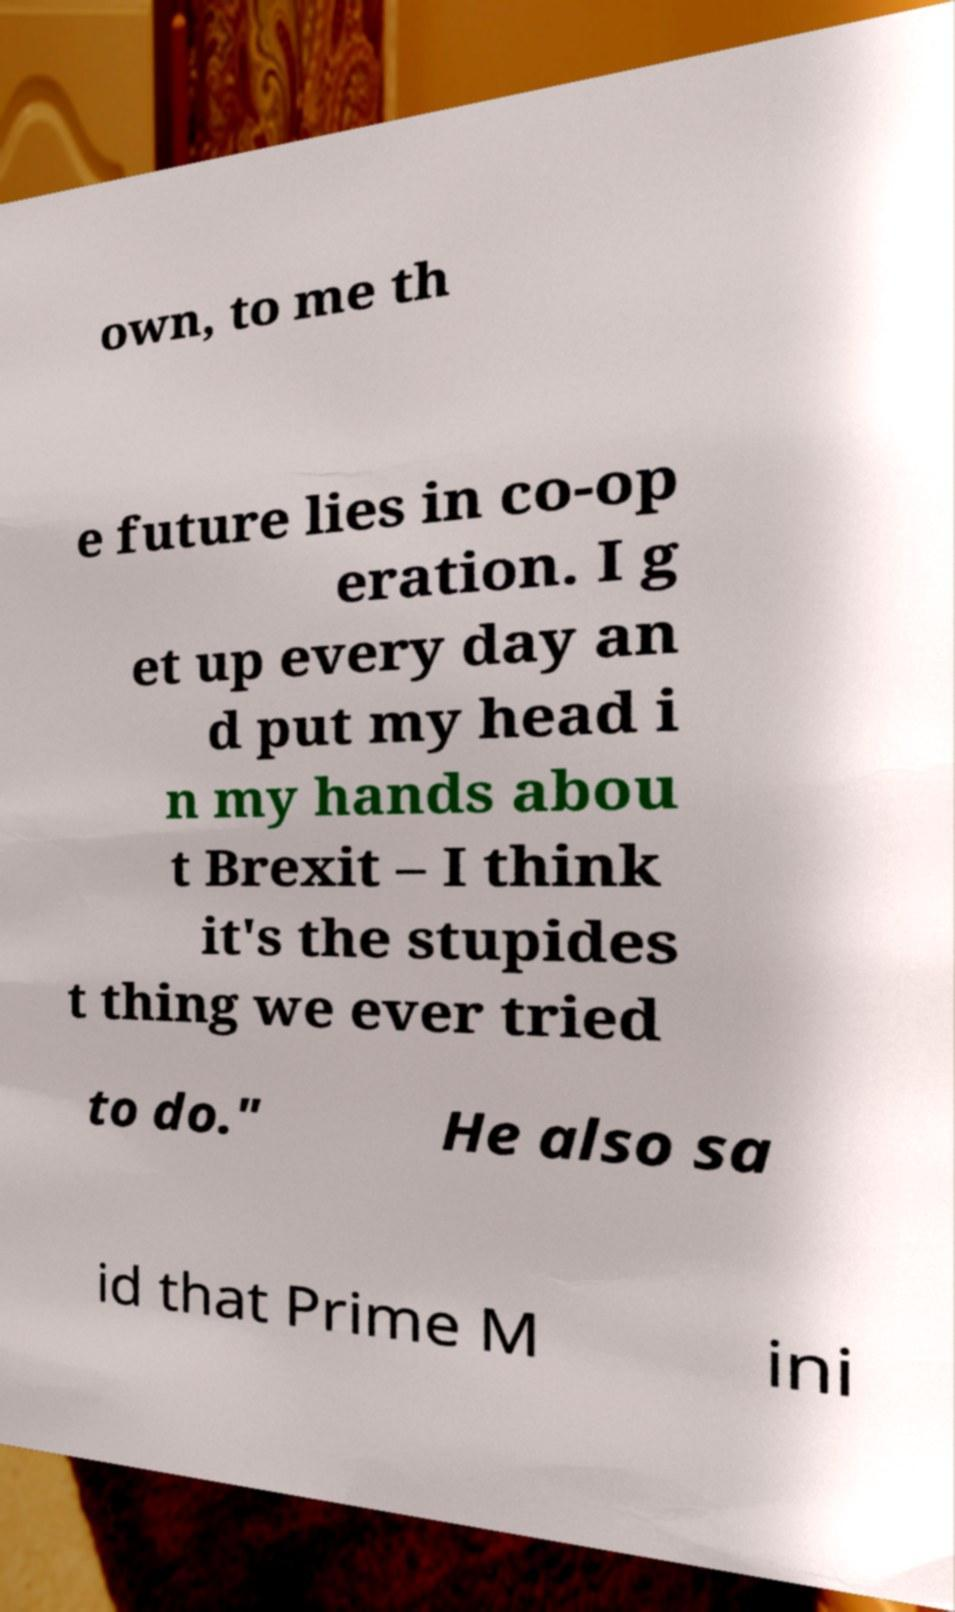Can you read and provide the text displayed in the image?This photo seems to have some interesting text. Can you extract and type it out for me? own, to me th e future lies in co-op eration. I g et up every day an d put my head i n my hands abou t Brexit – I think it's the stupides t thing we ever tried to do." He also sa id that Prime M ini 